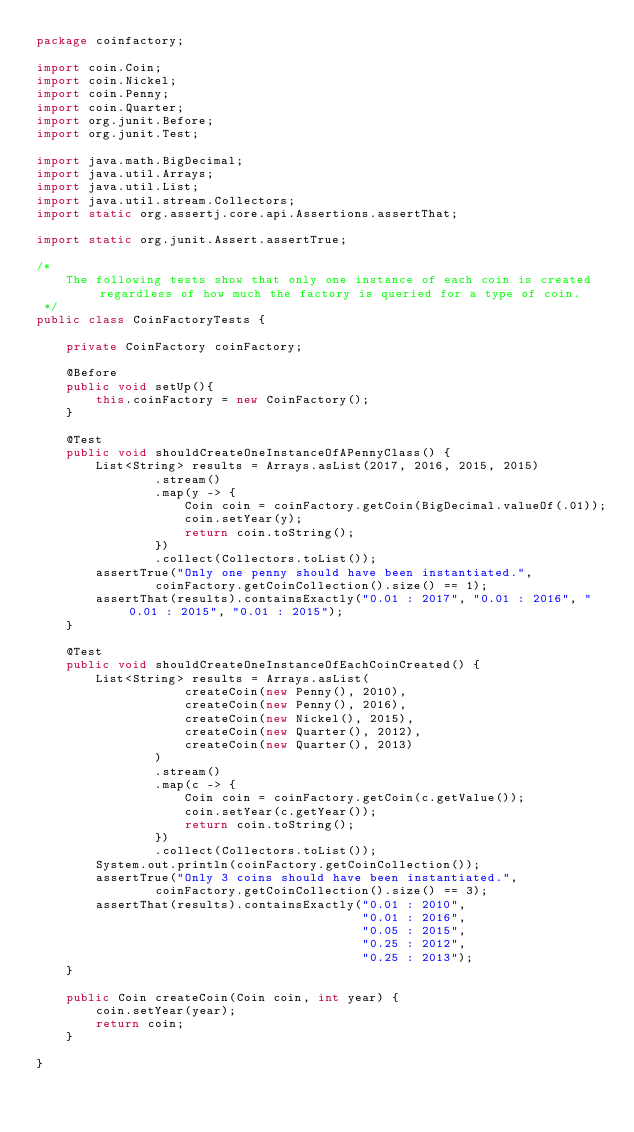<code> <loc_0><loc_0><loc_500><loc_500><_Java_>package coinfactory;

import coin.Coin;
import coin.Nickel;
import coin.Penny;
import coin.Quarter;
import org.junit.Before;
import org.junit.Test;

import java.math.BigDecimal;
import java.util.Arrays;
import java.util.List;
import java.util.stream.Collectors;
import static org.assertj.core.api.Assertions.assertThat;

import static org.junit.Assert.assertTrue;

/*
    The following tests show that only one instance of each coin is created regardless of how much the factory is queried for a type of coin.
 */
public class CoinFactoryTests {

    private CoinFactory coinFactory;

    @Before
    public void setUp(){
        this.coinFactory = new CoinFactory();
    }

    @Test
    public void shouldCreateOneInstanceOfAPennyClass() {
        List<String> results = Arrays.asList(2017, 2016, 2015, 2015)
                .stream()
                .map(y -> {
                    Coin coin = coinFactory.getCoin(BigDecimal.valueOf(.01));
                    coin.setYear(y);
                    return coin.toString();
                })
                .collect(Collectors.toList());
        assertTrue("Only one penny should have been instantiated.",
                coinFactory.getCoinCollection().size() == 1);
        assertThat(results).containsExactly("0.01 : 2017", "0.01 : 2016", "0.01 : 2015", "0.01 : 2015");
    }

    @Test
    public void shouldCreateOneInstanceOfEachCoinCreated() {
        List<String> results = Arrays.asList(
                    createCoin(new Penny(), 2010),
                    createCoin(new Penny(), 2016),
                    createCoin(new Nickel(), 2015),
                    createCoin(new Quarter(), 2012),
                    createCoin(new Quarter(), 2013)
                )
                .stream()
                .map(c -> {
                    Coin coin = coinFactory.getCoin(c.getValue());
                    coin.setYear(c.getYear());
                    return coin.toString();
                })
                .collect(Collectors.toList());
        System.out.println(coinFactory.getCoinCollection());
        assertTrue("Only 3 coins should have been instantiated.",
                coinFactory.getCoinCollection().size() == 3);
        assertThat(results).containsExactly("0.01 : 2010",
                                            "0.01 : 2016",
                                            "0.05 : 2015",
                                            "0.25 : 2012",
                                            "0.25 : 2013");
    }

    public Coin createCoin(Coin coin, int year) {
        coin.setYear(year);
        return coin;
    }

}
</code> 